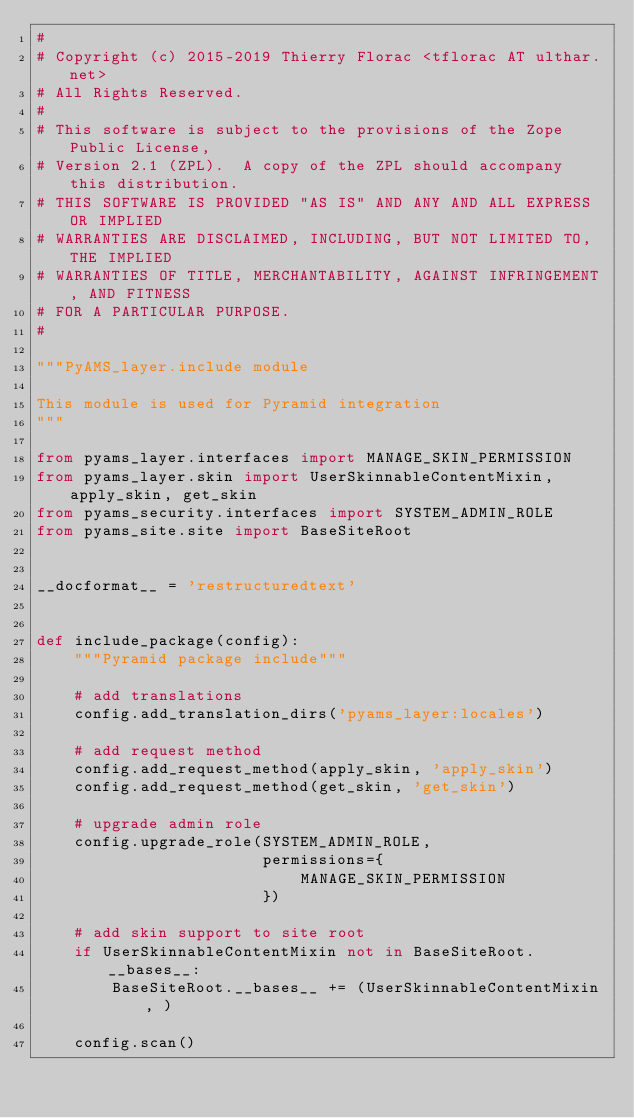Convert code to text. <code><loc_0><loc_0><loc_500><loc_500><_Python_>#
# Copyright (c) 2015-2019 Thierry Florac <tflorac AT ulthar.net>
# All Rights Reserved.
#
# This software is subject to the provisions of the Zope Public License,
# Version 2.1 (ZPL).  A copy of the ZPL should accompany this distribution.
# THIS SOFTWARE IS PROVIDED "AS IS" AND ANY AND ALL EXPRESS OR IMPLIED
# WARRANTIES ARE DISCLAIMED, INCLUDING, BUT NOT LIMITED TO, THE IMPLIED
# WARRANTIES OF TITLE, MERCHANTABILITY, AGAINST INFRINGEMENT, AND FITNESS
# FOR A PARTICULAR PURPOSE.
#

"""PyAMS_layer.include module

This module is used for Pyramid integration
"""

from pyams_layer.interfaces import MANAGE_SKIN_PERMISSION
from pyams_layer.skin import UserSkinnableContentMixin, apply_skin, get_skin
from pyams_security.interfaces import SYSTEM_ADMIN_ROLE
from pyams_site.site import BaseSiteRoot


__docformat__ = 'restructuredtext'


def include_package(config):
    """Pyramid package include"""

    # add translations
    config.add_translation_dirs('pyams_layer:locales')

    # add request method
    config.add_request_method(apply_skin, 'apply_skin')
    config.add_request_method(get_skin, 'get_skin')

    # upgrade admin role
    config.upgrade_role(SYSTEM_ADMIN_ROLE,
                        permissions={
                            MANAGE_SKIN_PERMISSION
                        })

    # add skin support to site root
    if UserSkinnableContentMixin not in BaseSiteRoot.__bases__:
        BaseSiteRoot.__bases__ += (UserSkinnableContentMixin, )

    config.scan()
</code> 